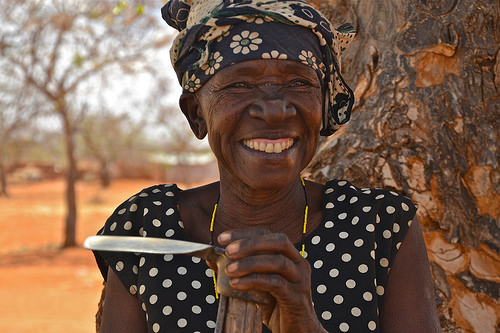<image>
Is the tree behind the women? Yes. From this viewpoint, the tree is positioned behind the women, with the women partially or fully occluding the tree. 